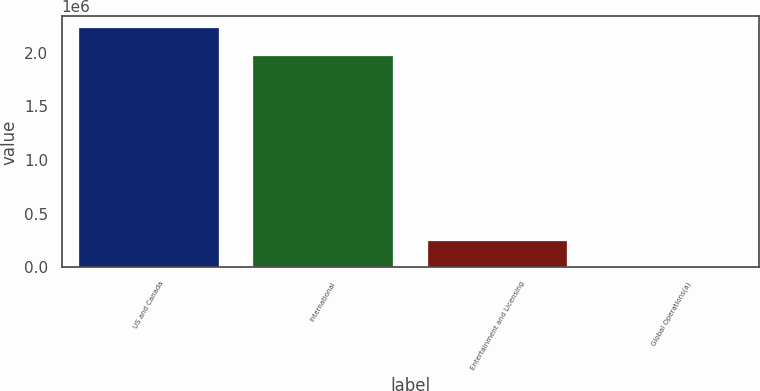<chart> <loc_0><loc_0><loc_500><loc_500><bar_chart><fcel>US and Canada<fcel>International<fcel>Entertainment and Licensing<fcel>Global Operations(a)<nl><fcel>2.22552e+06<fcel>1.97188e+06<fcel>244685<fcel>5431<nl></chart> 